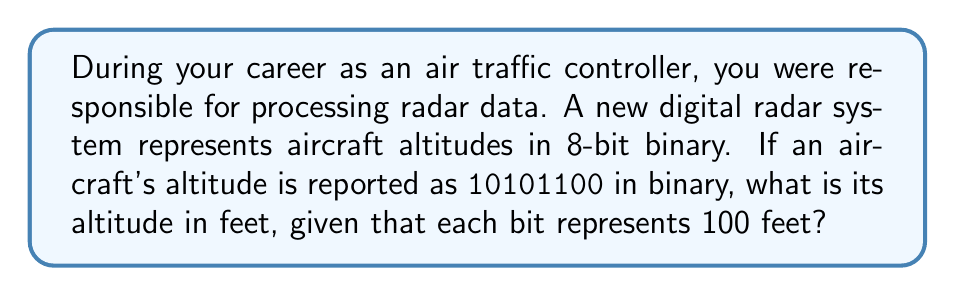Can you answer this question? To solve this problem, we need to convert the binary number to decimal and then multiply by the value each bit represents. Let's break it down step-by-step:

1. The binary number is 10101100.
2. To convert binary to decimal, we multiply each bit by its corresponding power of 2 and sum the results:

   $$(1 \times 2^7) + (0 \times 2^6) + (1 \times 2^5) + (0 \times 2^4) + (1 \times 2^3) + (1 \times 2^2) + (0 \times 2^1) + (0 \times 2^0)$$

3. Let's calculate each term:
   $$128 + 0 + 32 + 0 + 8 + 4 + 0 + 0 = 172$$

4. So, 10101100 in binary is equal to 172 in decimal.

5. Now, we know that each bit represents 100 feet. To get the altitude in feet, we multiply 172 by 100:

   $$172 \times 100 = 17,200\text{ feet}$$

Therefore, the aircraft's altitude is 17,200 feet.
Answer: 17,200 feet 